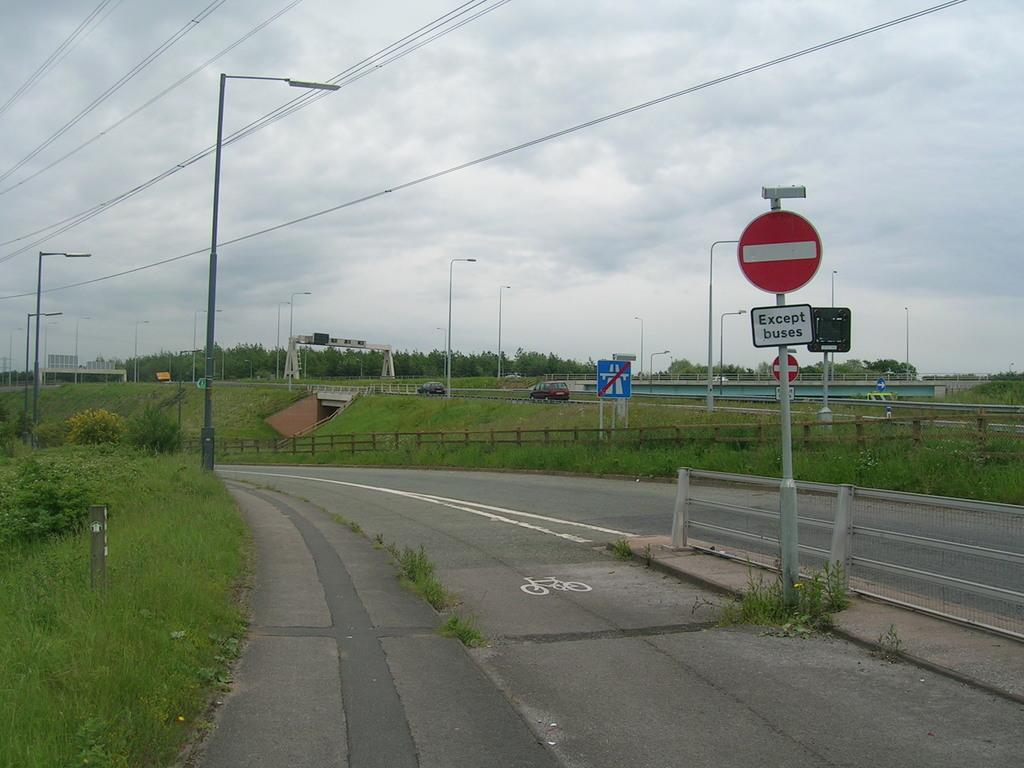Provide a one-sentence caption for the provided image. A deserted road near a farm with a no entry colored sign. 